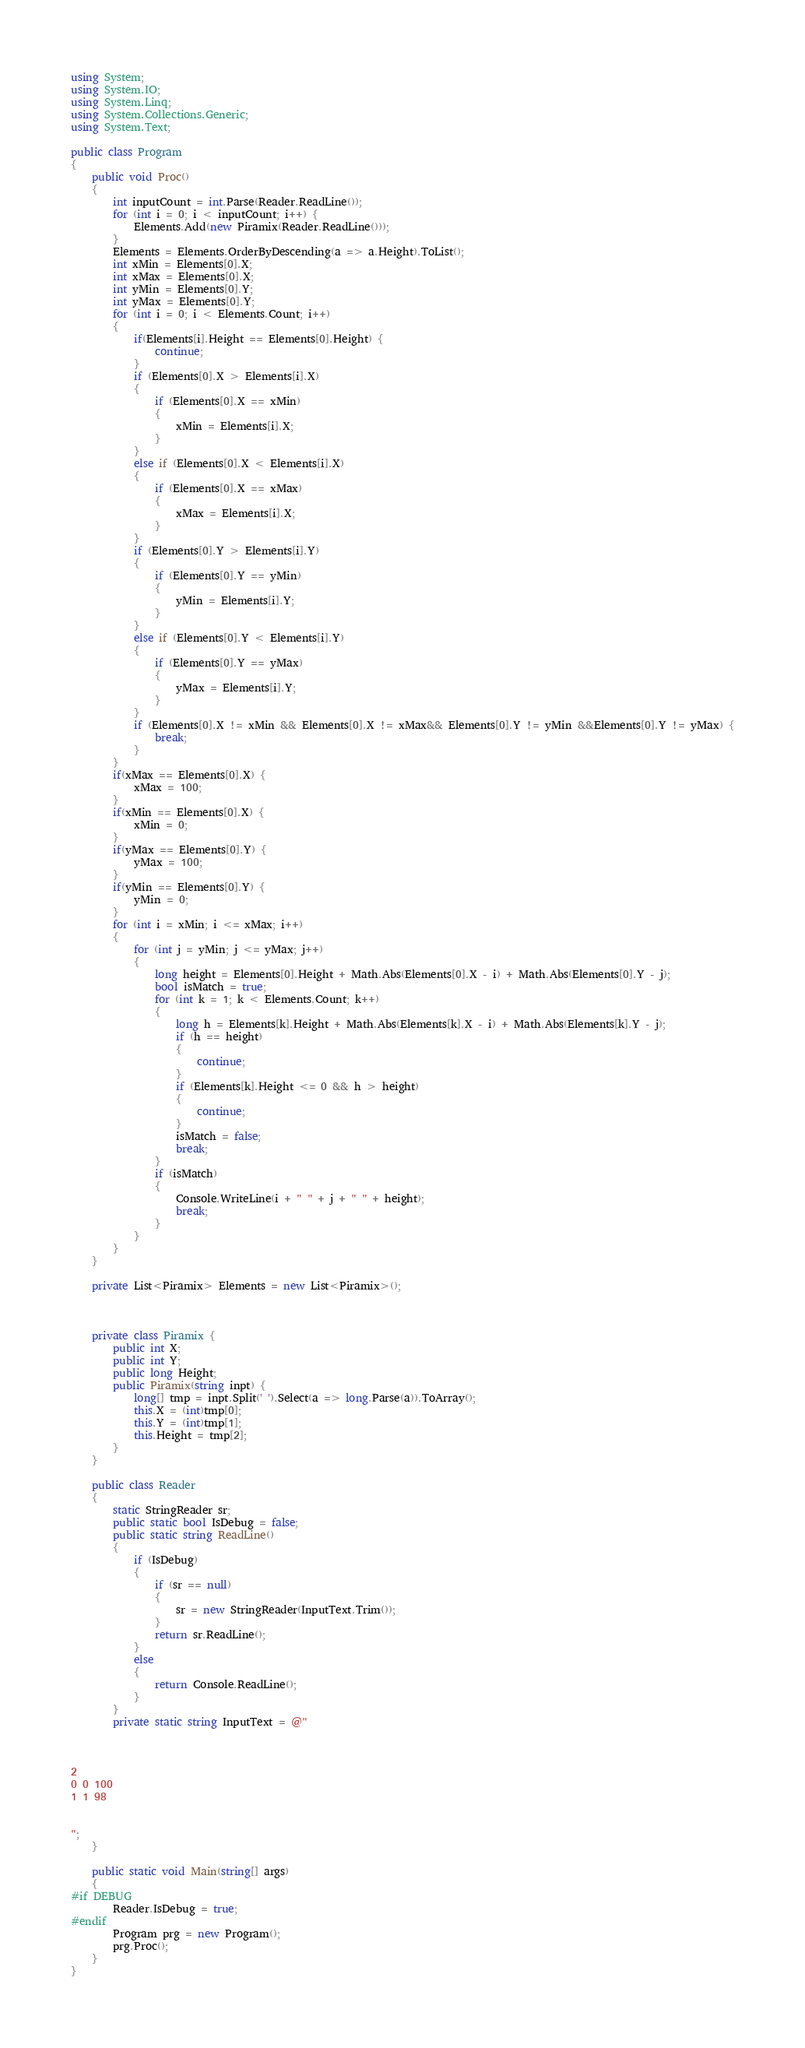Convert code to text. <code><loc_0><loc_0><loc_500><loc_500><_C#_>using System;
using System.IO;
using System.Linq;
using System.Collections.Generic;
using System.Text;

public class Program
{
    public void Proc()
    {
        int inputCount = int.Parse(Reader.ReadLine());
        for (int i = 0; i < inputCount; i++) {
            Elements.Add(new Piramix(Reader.ReadLine()));
        }
        Elements = Elements.OrderByDescending(a => a.Height).ToList();
        int xMin = Elements[0].X;
        int xMax = Elements[0].X;
        int yMin = Elements[0].Y;
        int yMax = Elements[0].Y;
        for (int i = 0; i < Elements.Count; i++)
        {
            if(Elements[i].Height == Elements[0].Height) {
                continue;
            }
            if (Elements[0].X > Elements[i].X)
            {
                if (Elements[0].X == xMin)
                {
                    xMin = Elements[i].X;
                }
            }
            else if (Elements[0].X < Elements[i].X)
            {
                if (Elements[0].X == xMax)
                {
                    xMax = Elements[i].X;
                }
            }
            if (Elements[0].Y > Elements[i].Y)
            {
                if (Elements[0].Y == yMin)
                {
                    yMin = Elements[i].Y;
                }
            }
            else if (Elements[0].Y < Elements[i].Y)
            {
                if (Elements[0].Y == yMax)
                {
                    yMax = Elements[i].Y;
                }
            }
            if (Elements[0].X != xMin && Elements[0].X != xMax&& Elements[0].Y != yMin &&Elements[0].Y != yMax) {
                break;
            }
        }
        if(xMax == Elements[0].X) {
            xMax = 100;
        }
        if(xMin == Elements[0].X) {
            xMin = 0;
        }
        if(yMax == Elements[0].Y) {
            yMax = 100;
        }
        if(yMin == Elements[0].Y) {
            yMin = 0;
        }
        for (int i = xMin; i <= xMax; i++)
        {
            for (int j = yMin; j <= yMax; j++)
            {
                long height = Elements[0].Height + Math.Abs(Elements[0].X - i) + Math.Abs(Elements[0].Y - j);
                bool isMatch = true;
                for (int k = 1; k < Elements.Count; k++)
                {
                    long h = Elements[k].Height + Math.Abs(Elements[k].X - i) + Math.Abs(Elements[k].Y - j);
                    if (h == height)
                    {
                        continue;
                    }
                    if (Elements[k].Height <= 0 && h > height)
                    {
                        continue;
                    }
                    isMatch = false;
                    break;
                }
                if (isMatch)
                {
                    Console.WriteLine(i + " " + j + " " + height);
                    break;
                }
            }
        }
    }

    private List<Piramix> Elements = new List<Piramix>();



    private class Piramix {
        public int X;
        public int Y;
        public long Height;
        public Piramix(string inpt) {
            long[] tmp = inpt.Split(' ').Select(a => long.Parse(a)).ToArray();
            this.X = (int)tmp[0];
            this.Y = (int)tmp[1];
            this.Height = tmp[2];
        }
    }

    public class Reader
    {
        static StringReader sr;
        public static bool IsDebug = false;
        public static string ReadLine()
        {
            if (IsDebug)
            {
                if (sr == null)
                {
                    sr = new StringReader(InputText.Trim());
                }
                return sr.ReadLine();
            }
            else
            {
                return Console.ReadLine();
            }
        }
        private static string InputText = @"



2
0 0 100
1 1 98


";
    }

    public static void Main(string[] args)
    {
#if DEBUG
        Reader.IsDebug = true;
#endif
        Program prg = new Program();
        prg.Proc();
    }
}
</code> 